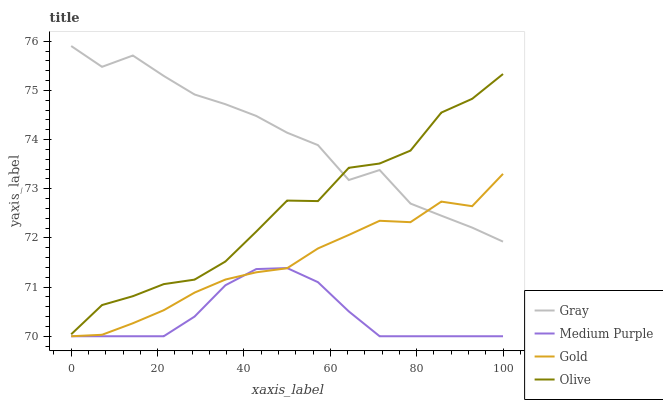Does Medium Purple have the minimum area under the curve?
Answer yes or no. Yes. Does Gray have the maximum area under the curve?
Answer yes or no. Yes. Does Gold have the minimum area under the curve?
Answer yes or no. No. Does Gold have the maximum area under the curve?
Answer yes or no. No. Is Medium Purple the smoothest?
Answer yes or no. Yes. Is Olive the roughest?
Answer yes or no. Yes. Is Gray the smoothest?
Answer yes or no. No. Is Gray the roughest?
Answer yes or no. No. Does Medium Purple have the lowest value?
Answer yes or no. Yes. Does Gray have the lowest value?
Answer yes or no. No. Does Gray have the highest value?
Answer yes or no. Yes. Does Gold have the highest value?
Answer yes or no. No. Is Gold less than Olive?
Answer yes or no. Yes. Is Gray greater than Medium Purple?
Answer yes or no. Yes. Does Gold intersect Gray?
Answer yes or no. Yes. Is Gold less than Gray?
Answer yes or no. No. Is Gold greater than Gray?
Answer yes or no. No. Does Gold intersect Olive?
Answer yes or no. No. 